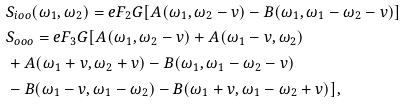<formula> <loc_0><loc_0><loc_500><loc_500>& S _ { i o o } ( \omega _ { 1 } , \omega _ { 2 } ) = e F _ { 2 } G [ A ( \omega _ { 1 } , \omega _ { 2 } - v ) - B ( \omega _ { 1 } , \omega _ { 1 } - \omega _ { 2 } - v ) ] \\ & S _ { o o o } = e F _ { 3 } G [ A ( \omega _ { 1 } , \omega _ { 2 } - v ) + A ( \omega _ { 1 } - v , \omega _ { 2 } ) \\ & + A ( \omega _ { 1 } + v , \omega _ { 2 } + v ) - B ( \omega _ { 1 } , \omega _ { 1 } - \omega _ { 2 } - v ) \\ & - B ( \omega _ { 1 } - v , \omega _ { 1 } - \omega _ { 2 } ) - B ( \omega _ { 1 } + v , \omega _ { 1 } - \omega _ { 2 } + v ) ] ,</formula> 